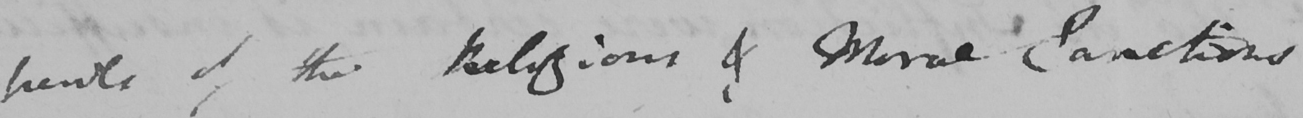What text is written in this handwritten line? trends of the Religious & Moral Sanctions 